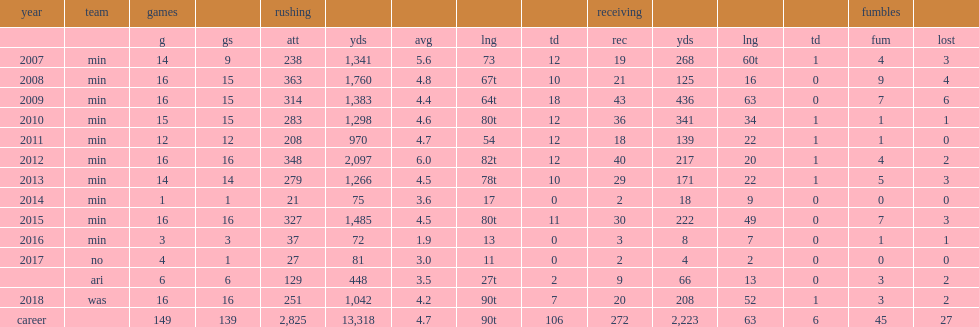How many rushing yards did peterson get in 2018? 1042.0. 